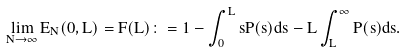<formula> <loc_0><loc_0><loc_500><loc_500>\lim _ { N \to \infty } E _ { N } ( 0 , L ) = F ( L ) \colon = 1 - \int _ { 0 } ^ { L } s P ( s ) d s - L \int _ { L } ^ { \infty } P ( s ) d s .</formula> 